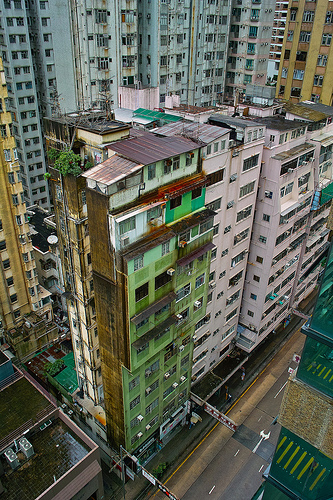<image>
Is the roof behind the window? No. The roof is not behind the window. From this viewpoint, the roof appears to be positioned elsewhere in the scene. 